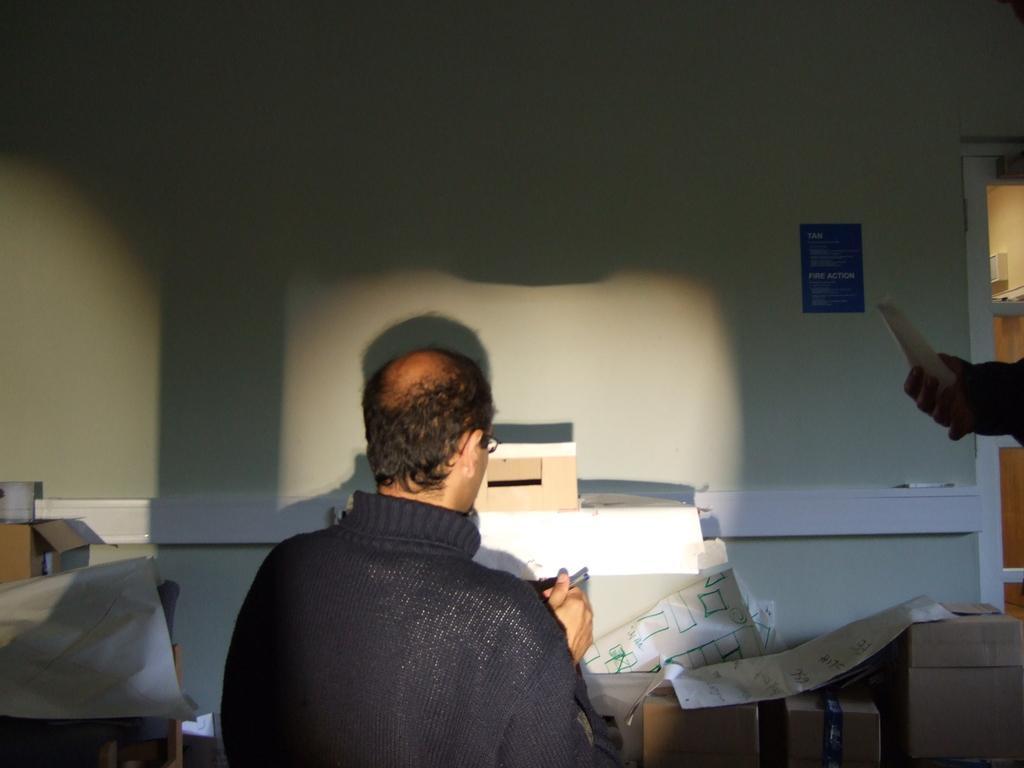Can you describe this image briefly? In this picture I can see a man in front and in the background I can see number of boxes, few papers and I can see the wall. On the right side of this picture I can see a blue color thing on the wall and I can also see a hand of a person and there is something in the hand. 